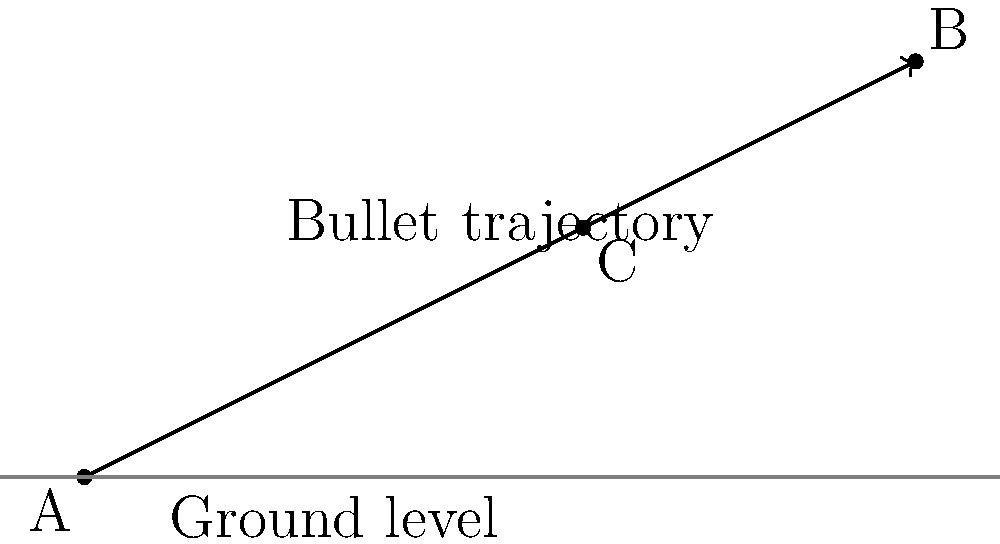During a crime scene investigation, a bullet trajectory is found to pass through points A(0,0) and B(10,5). A witness reports seeing the muzzle flash at point C(6,3). Calculate the angle (in degrees) between the actual bullet trajectory and the line connecting the witness's reported position to the bullet's impact point. To solve this problem, we'll follow these steps:

1. Calculate the slope of the bullet trajectory (line AB):
   $m_{AB} = \frac{y_B - y_A}{x_B - x_A} = \frac{5 - 0}{10 - 0} = \frac{1}{2}$

2. Calculate the slope of the witness's line of sight (line AC):
   $m_{AC} = \frac{y_C - y_A}{x_C - x_A} = \frac{3 - 0}{6 - 0} = \frac{1}{2}$

3. Use the formula for the angle between two lines:
   $\tan \theta = |\frac{m_1 - m_2}{1 + m_1m_2}|$

   Where $m_1 = m_{AB}$ and $m_2 = m_{AC}$

4. Substitute the values:
   $\tan \theta = |\frac{\frac{1}{2} - \frac{1}{2}}{1 + \frac{1}{2} \cdot \frac{1}{2}}| = |\frac{0}{1 + \frac{1}{4}}| = 0$

5. Since $\tan \theta = 0$, the angle $\theta = 0°$

Therefore, the angle between the actual bullet trajectory and the witness's line of sight is 0°, meaning they are parallel.
Answer: 0° 